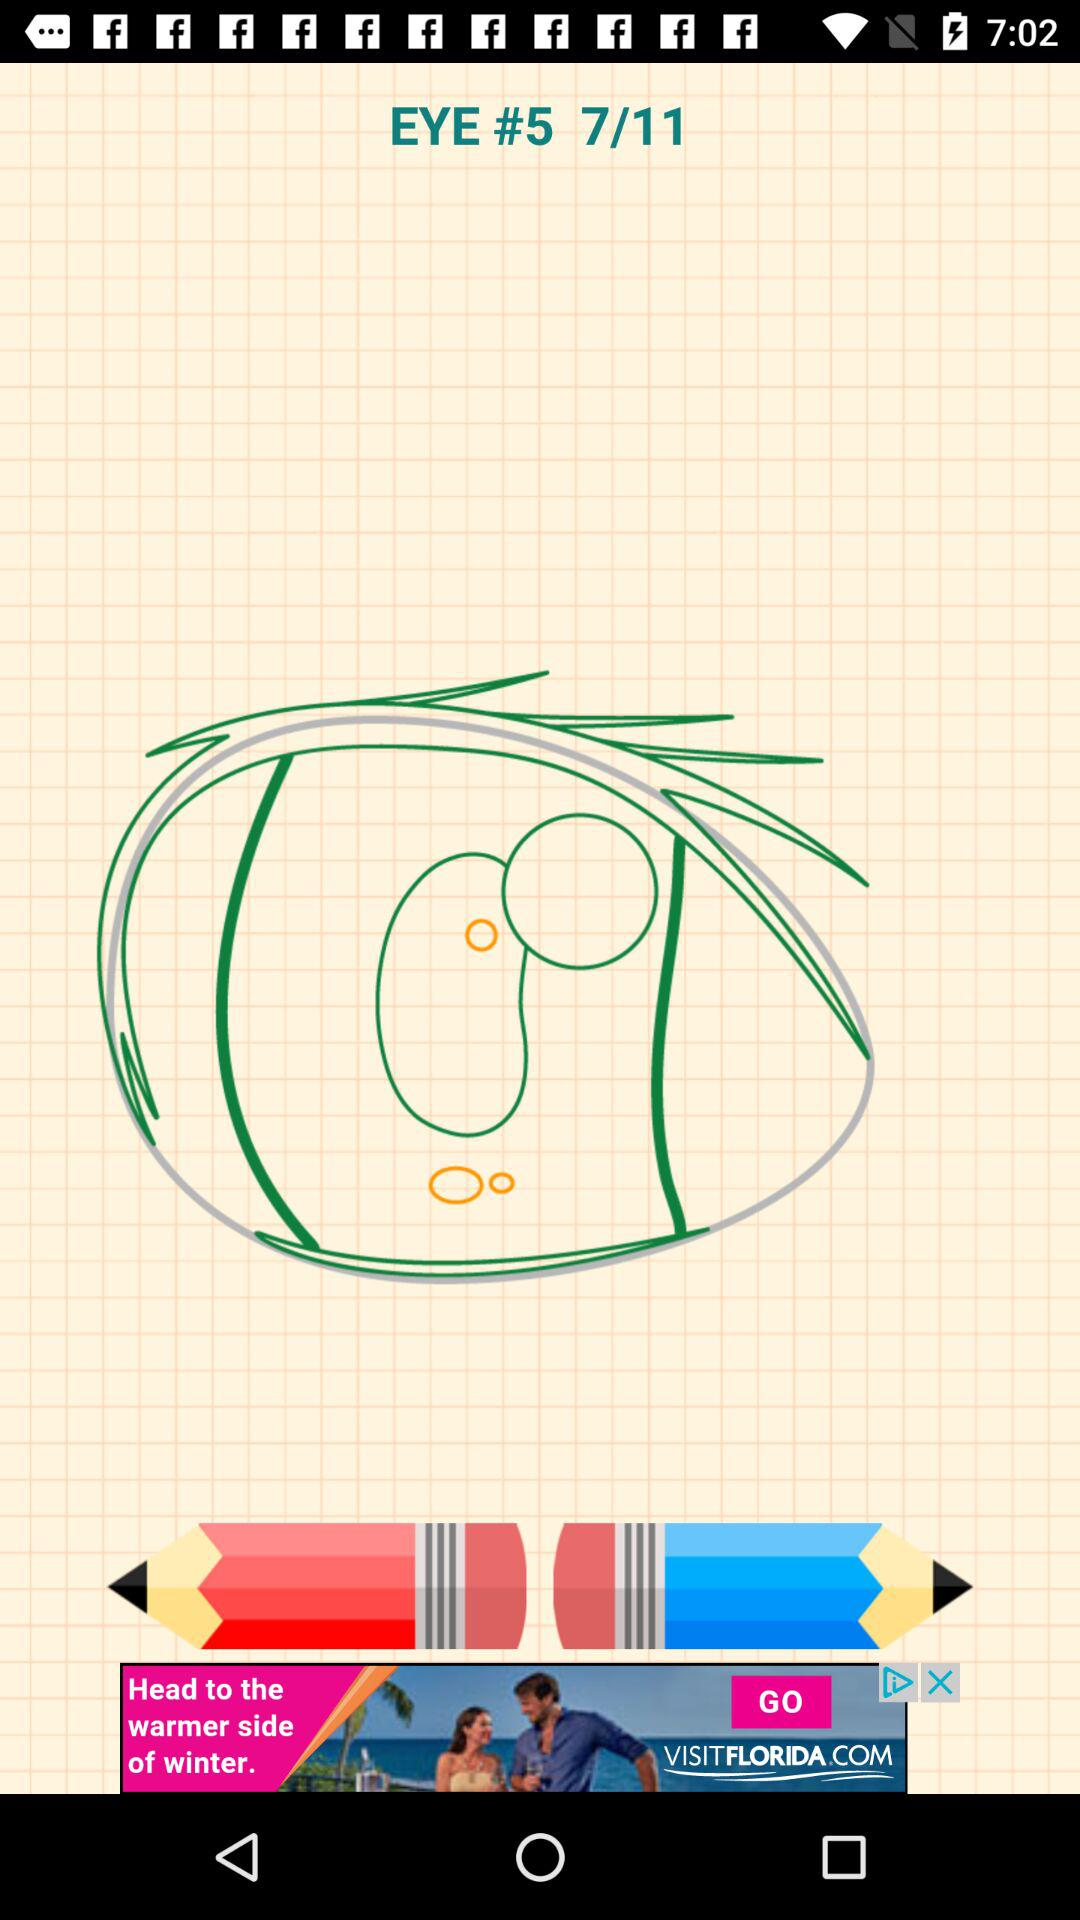At which step are we? You are at step 7. 